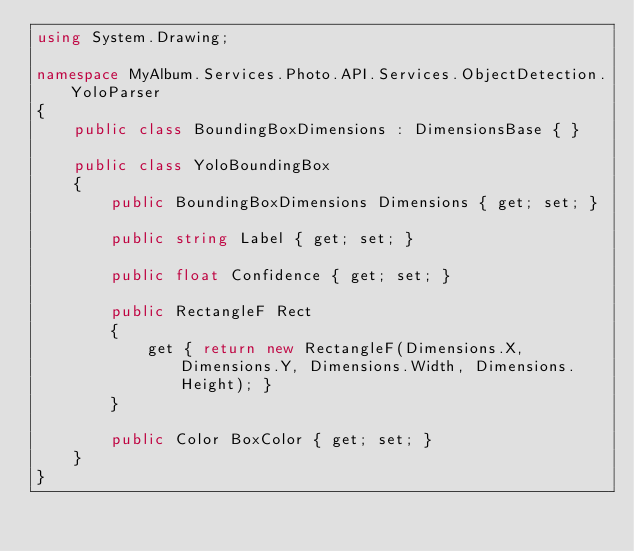<code> <loc_0><loc_0><loc_500><loc_500><_C#_>using System.Drawing;

namespace MyAlbum.Services.Photo.API.Services.ObjectDetection.YoloParser
{
    public class BoundingBoxDimensions : DimensionsBase { }

    public class YoloBoundingBox
    {
        public BoundingBoxDimensions Dimensions { get; set; }

        public string Label { get; set; }

        public float Confidence { get; set; }

        public RectangleF Rect
        {
            get { return new RectangleF(Dimensions.X, Dimensions.Y, Dimensions.Width, Dimensions.Height); }
        }

        public Color BoxColor { get; set; }        
    }
}</code> 